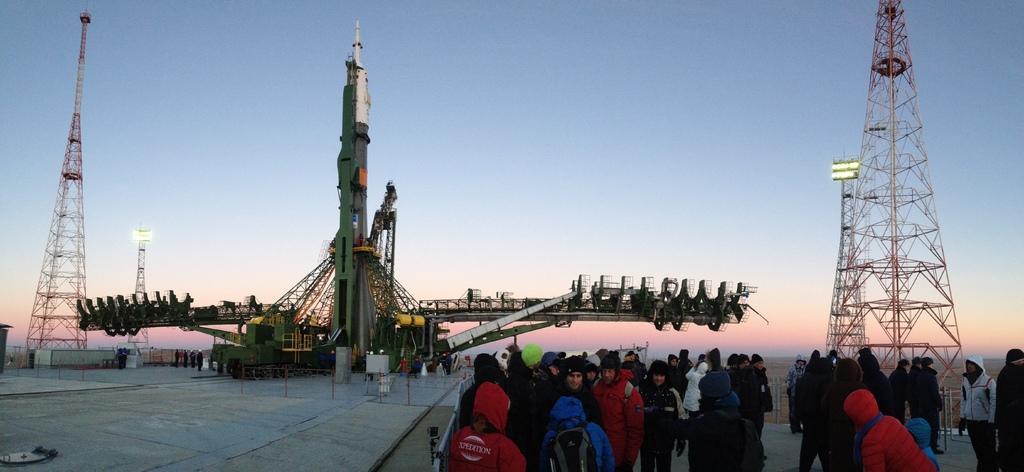Describe this image in one or two sentences. In the image we can see there are many people around, they are wearing clothes. Here we can see, towers and a rocket. There is a platform and a sky. 